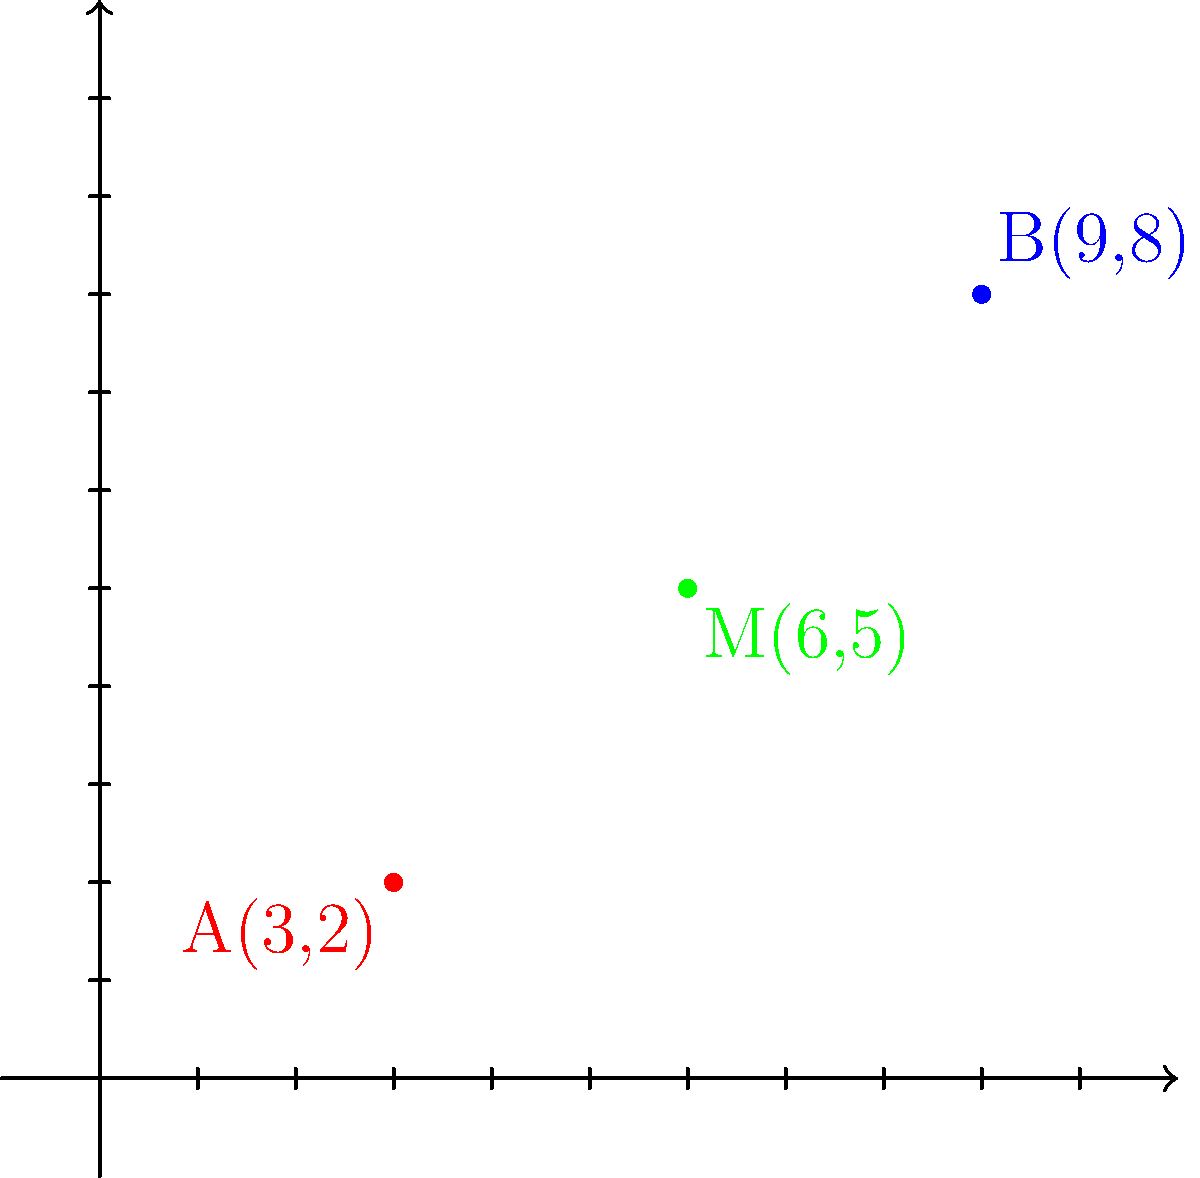In a partnered dance routine, two dancers start at different positions on a coordinate plane. Dancer A begins at point (3,2), while Dancer B starts at point (9,8). To synchronize their movements, they need to meet at the midpoint of their starting positions. Calculate the coordinates of this midpoint M and explain its significance in analyzing the dancers' spatial relationship during the routine. To find the midpoint M between two points A(x₁, y₁) and B(x₂, y₂), we use the midpoint formula:

$$ M_x = \frac{x_1 + x_2}{2}, \quad M_y = \frac{y_1 + y_2}{2} $$

Given:
- Dancer A's position: A(3, 2)
- Dancer B's position: B(9, 8)

Step 1: Calculate the x-coordinate of the midpoint:
$$ M_x = \frac{x_1 + x_2}{2} = \frac{3 + 9}{2} = \frac{12}{2} = 6 $$

Step 2: Calculate the y-coordinate of the midpoint:
$$ M_y = \frac{y_1 + y_2}{2} = \frac{2 + 8}{2} = \frac{10}{2} = 5 $$

Step 3: Combine the results to get the midpoint coordinates:
M(6, 5)

Significance in analyzing dancers' spatial relationship:
1. Symmetry: The midpoint represents a balanced position between the two dancers, crucial for maintaining visual harmony in the routine.
2. Distance: Both dancers will travel equal distances to reach this point, which is important for timing and coordination.
3. Reference point: The midpoint can serve as a reference for other movements or formations in the choreography.
4. Energy expenditure: Understanding the midpoint helps in analyzing the energy required for both dancers to meet, ensuring fair distribution of effort.
5. Spatial awareness: Knowing the midpoint enhances the dancers' ability to gauge their relative positions and movements on stage.
Answer: M(6, 5) 